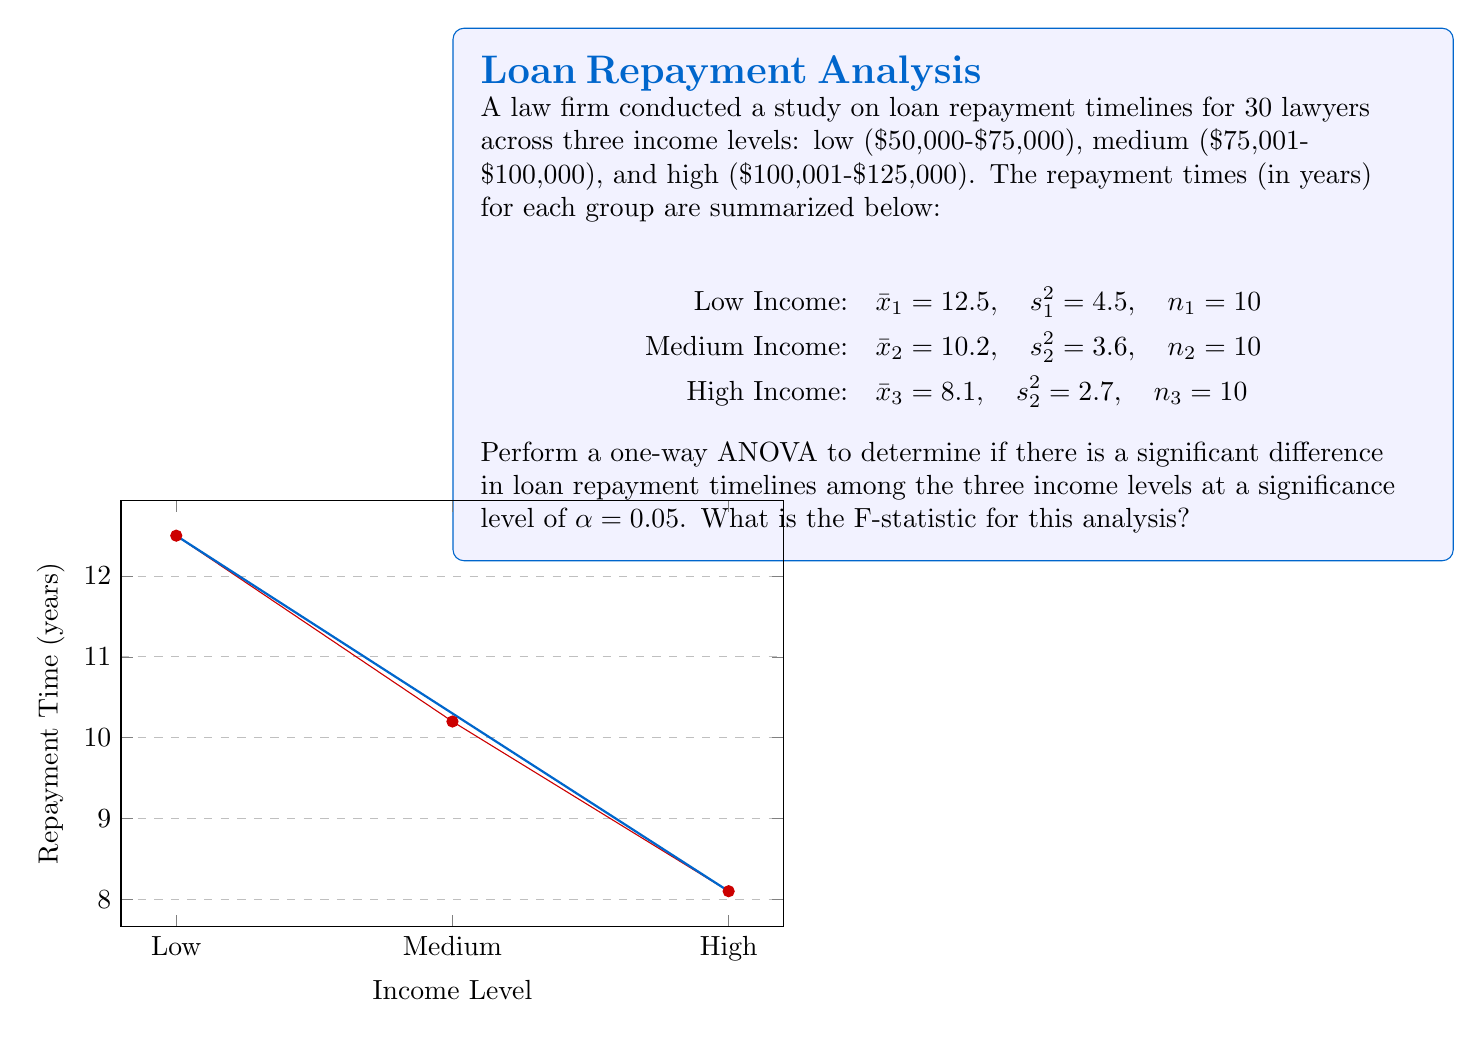Solve this math problem. To perform a one-way ANOVA, we need to calculate the following:

1. Sum of Squares Between (SSB)
2. Sum of Squares Within (SSW)
3. Mean Square Between (MSB)
4. Mean Square Within (MSW)
5. F-statistic

Step 1: Calculate the grand mean
$$\bar{x} = \frac{n_1\bar{x}_1 + n_2\bar{x}_2 + n_3\bar{x}_3}{n_1 + n_2 + n_3} = \frac{10(12.5) + 10(10.2) + 10(8.1)}{30} = 10.27$$

Step 2: Calculate SSB
$$SSB = n_1(\bar{x}_1 - \bar{x})^2 + n_2(\bar{x}_2 - \bar{x})^2 + n_3(\bar{x}_3 - \bar{x})^2$$
$$SSB = 10(12.5 - 10.27)^2 + 10(10.2 - 10.27)^2 + 10(8.1 - 10.27)^2 = 108.82$$

Step 3: Calculate SSW
$$SSW = (n_1 - 1)s_1^2 + (n_2 - 1)s_2^2 + (n_3 - 1)s_3^2$$
$$SSW = 9(4.5) + 9(3.6) + 9(2.7) = 97.2$$

Step 4: Calculate degrees of freedom
$$df_{between} = k - 1 = 3 - 1 = 2$$
$$df_{within} = N - k = 30 - 3 = 27$$
where k is the number of groups and N is the total sample size.

Step 5: Calculate MSB and MSW
$$MSB = \frac{SSB}{df_{between}} = \frac{108.82}{2} = 54.41$$
$$MSW = \frac{SSW}{df_{within}} = \frac{97.2}{27} = 3.60$$

Step 6: Calculate the F-statistic
$$F = \frac{MSB}{MSW} = \frac{54.41}{3.60} = 15.11$$

Therefore, the F-statistic for this analysis is 15.11.
Answer: $F = 15.11$ 